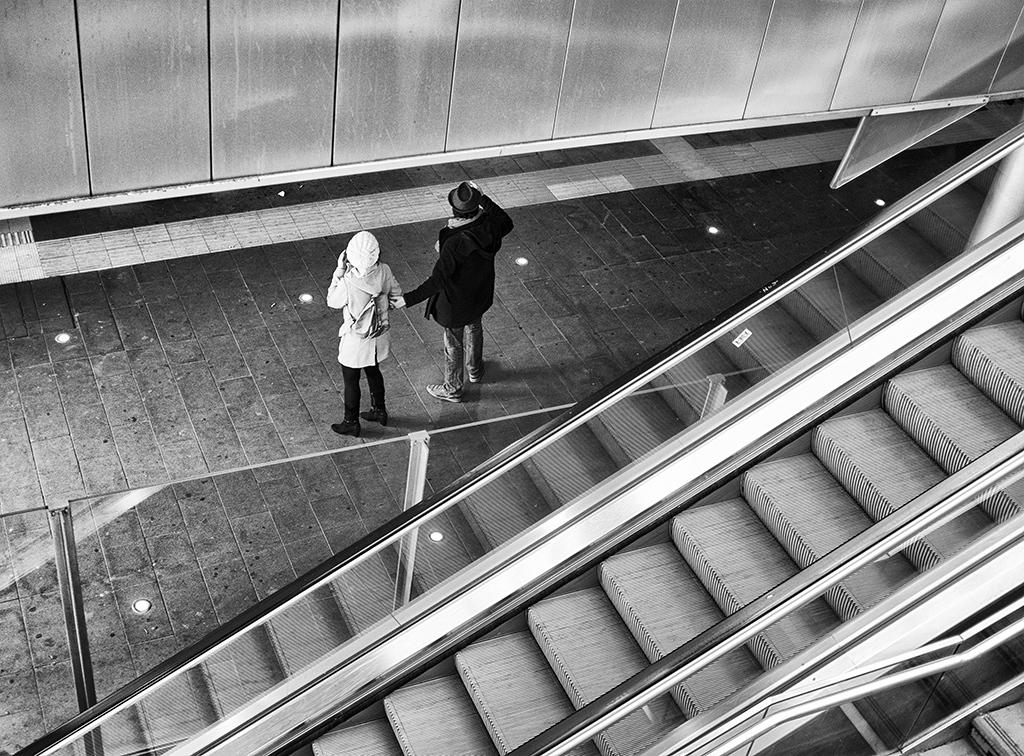What is the color scheme of the image? The image is black and white. How many people are present in the image? There are two people standing in the image. What objects can be seen in the image besides the people? There are poles, a staircase, and a wall in the image. What type of instrument is being played by the people in the image? There is no instrument present in the image; the people are simply standing. Can you see any animals in the image, such as those found in a zoo? There are no animals visible in the image; it features two people standing near poles, a staircase, and a wall. 